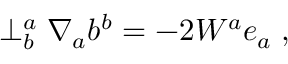Convert formula to latex. <formula><loc_0><loc_0><loc_500><loc_500>\perp _ { b } ^ { a } \nabla _ { a } b ^ { b } = - 2 W ^ { a } e _ { a } \, ,</formula> 